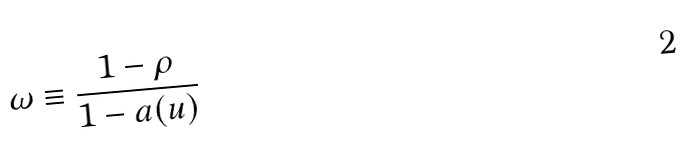<formula> <loc_0><loc_0><loc_500><loc_500>\omega \equiv \frac { 1 - \rho } { 1 - a ( u ) }</formula> 